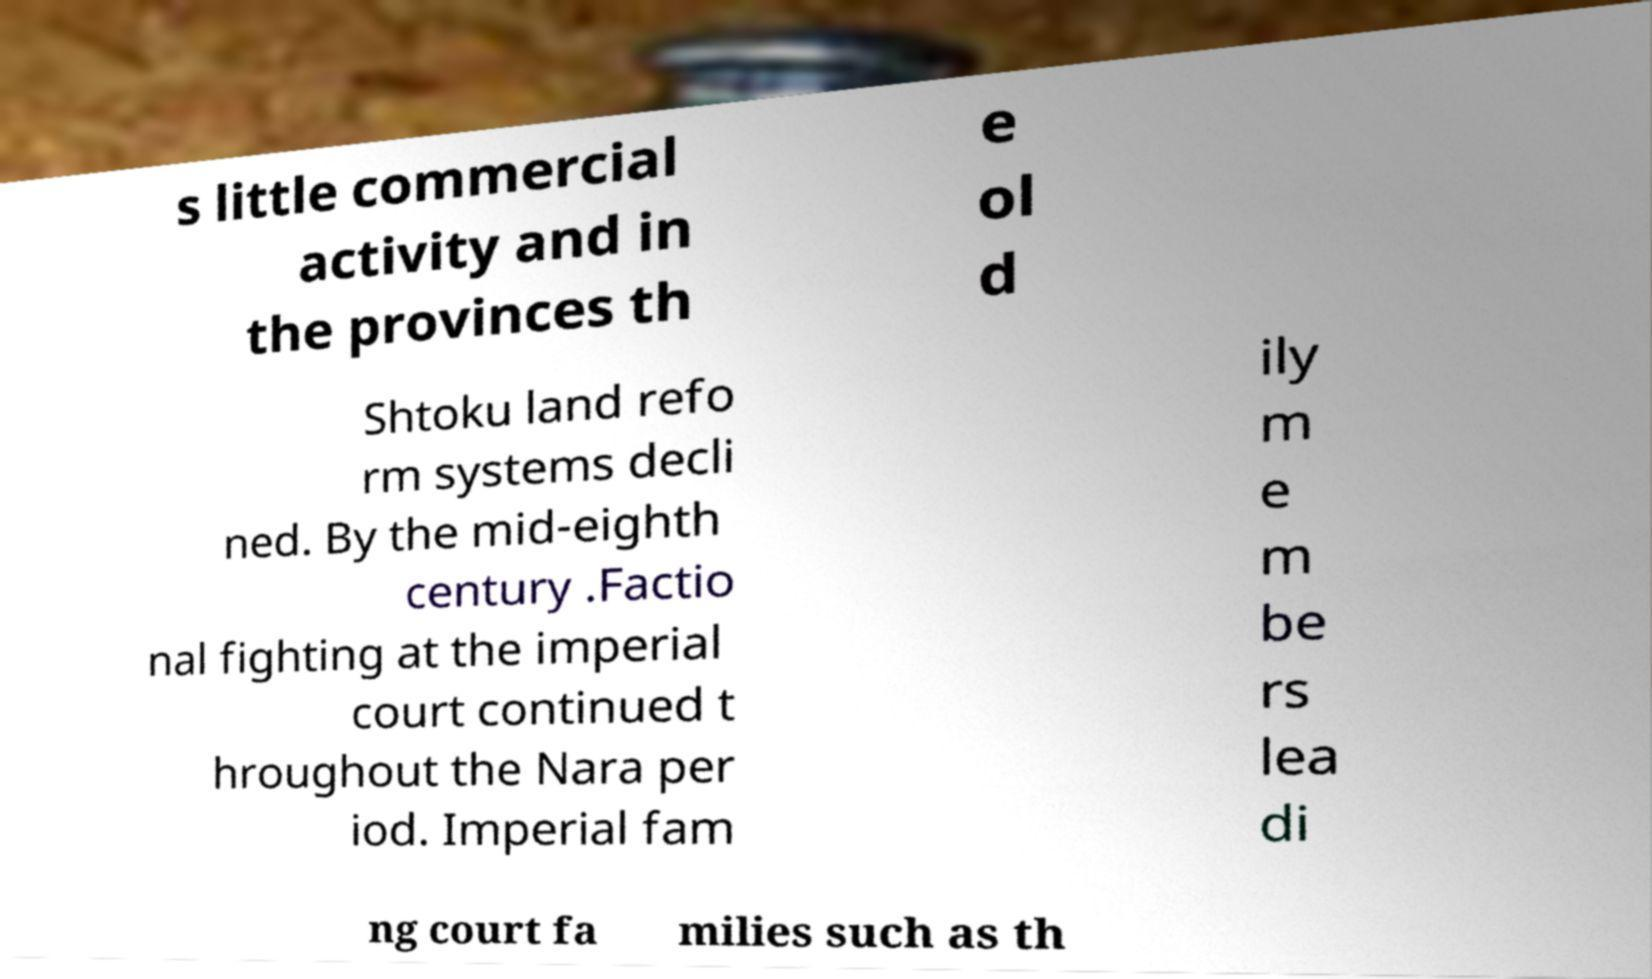Please read and relay the text visible in this image. What does it say? s little commercial activity and in the provinces th e ol d Shtoku land refo rm systems decli ned. By the mid-eighth century .Factio nal fighting at the imperial court continued t hroughout the Nara per iod. Imperial fam ily m e m be rs lea di ng court fa milies such as th 